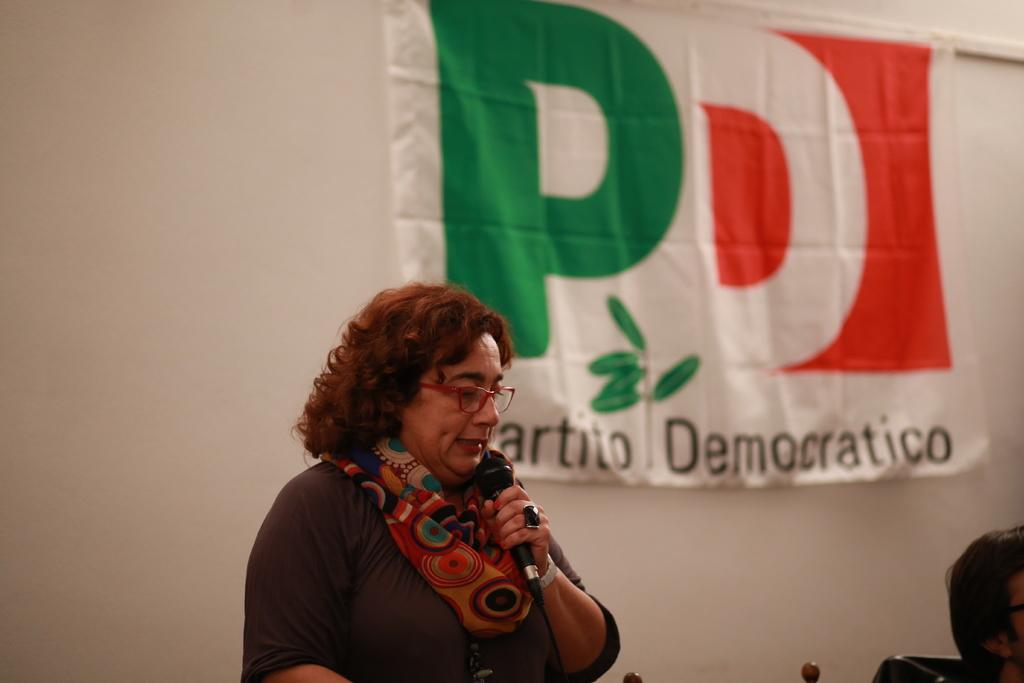What is the lady in the center of the image doing? The lady is standing in the center of the image and holding a mic. Who else is present in the image? There is a person on the right side of the image. What can be seen in the background of the image? There is a banner and a wall in the background of the image. What type of texture can be seen on the berries in the image? There are no berries present in the image, so it is not possible to determine their texture. 